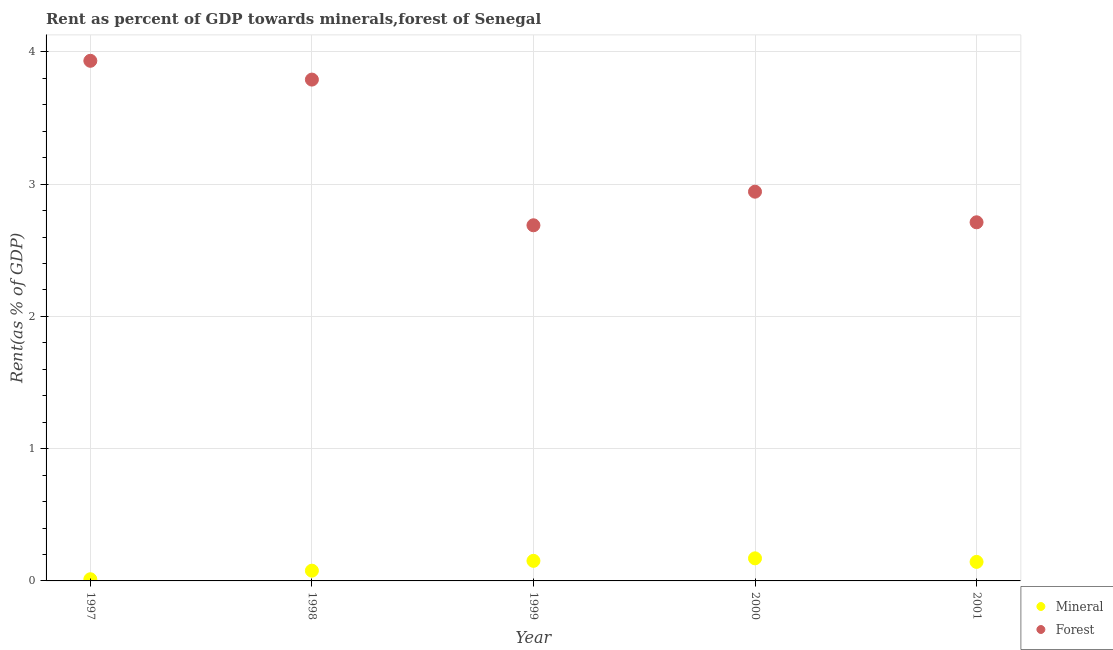How many different coloured dotlines are there?
Ensure brevity in your answer.  2. Is the number of dotlines equal to the number of legend labels?
Make the answer very short. Yes. What is the forest rent in 1998?
Make the answer very short. 3.79. Across all years, what is the maximum forest rent?
Provide a succinct answer. 3.93. Across all years, what is the minimum forest rent?
Offer a very short reply. 2.69. What is the total forest rent in the graph?
Provide a short and direct response. 16.07. What is the difference between the mineral rent in 1997 and that in 1999?
Offer a very short reply. -0.14. What is the difference between the forest rent in 1997 and the mineral rent in 1999?
Offer a terse response. 3.78. What is the average forest rent per year?
Your answer should be compact. 3.21. In the year 1997, what is the difference between the forest rent and mineral rent?
Your response must be concise. 3.92. In how many years, is the forest rent greater than 2.6 %?
Give a very brief answer. 5. What is the ratio of the forest rent in 1998 to that in 2000?
Make the answer very short. 1.29. Is the difference between the forest rent in 1997 and 2000 greater than the difference between the mineral rent in 1997 and 2000?
Ensure brevity in your answer.  Yes. What is the difference between the highest and the second highest forest rent?
Offer a very short reply. 0.14. What is the difference between the highest and the lowest forest rent?
Your answer should be compact. 1.24. How many dotlines are there?
Make the answer very short. 2. How many years are there in the graph?
Make the answer very short. 5. What is the difference between two consecutive major ticks on the Y-axis?
Make the answer very short. 1. Are the values on the major ticks of Y-axis written in scientific E-notation?
Provide a short and direct response. No. Does the graph contain any zero values?
Offer a very short reply. No. Does the graph contain grids?
Make the answer very short. Yes. Where does the legend appear in the graph?
Make the answer very short. Bottom right. How are the legend labels stacked?
Provide a succinct answer. Vertical. What is the title of the graph?
Provide a short and direct response. Rent as percent of GDP towards minerals,forest of Senegal. Does "Chemicals" appear as one of the legend labels in the graph?
Offer a very short reply. No. What is the label or title of the Y-axis?
Offer a very short reply. Rent(as % of GDP). What is the Rent(as % of GDP) of Mineral in 1997?
Keep it short and to the point. 0.01. What is the Rent(as % of GDP) in Forest in 1997?
Give a very brief answer. 3.93. What is the Rent(as % of GDP) of Mineral in 1998?
Ensure brevity in your answer.  0.08. What is the Rent(as % of GDP) of Forest in 1998?
Give a very brief answer. 3.79. What is the Rent(as % of GDP) in Mineral in 1999?
Offer a very short reply. 0.15. What is the Rent(as % of GDP) of Forest in 1999?
Give a very brief answer. 2.69. What is the Rent(as % of GDP) of Mineral in 2000?
Make the answer very short. 0.17. What is the Rent(as % of GDP) of Forest in 2000?
Your response must be concise. 2.94. What is the Rent(as % of GDP) of Mineral in 2001?
Ensure brevity in your answer.  0.14. What is the Rent(as % of GDP) in Forest in 2001?
Your answer should be very brief. 2.71. Across all years, what is the maximum Rent(as % of GDP) of Mineral?
Your answer should be compact. 0.17. Across all years, what is the maximum Rent(as % of GDP) in Forest?
Offer a very short reply. 3.93. Across all years, what is the minimum Rent(as % of GDP) in Mineral?
Offer a very short reply. 0.01. Across all years, what is the minimum Rent(as % of GDP) in Forest?
Keep it short and to the point. 2.69. What is the total Rent(as % of GDP) of Mineral in the graph?
Provide a succinct answer. 0.56. What is the total Rent(as % of GDP) in Forest in the graph?
Make the answer very short. 16.07. What is the difference between the Rent(as % of GDP) in Mineral in 1997 and that in 1998?
Your answer should be very brief. -0.06. What is the difference between the Rent(as % of GDP) of Forest in 1997 and that in 1998?
Your answer should be very brief. 0.14. What is the difference between the Rent(as % of GDP) of Mineral in 1997 and that in 1999?
Give a very brief answer. -0.14. What is the difference between the Rent(as % of GDP) in Forest in 1997 and that in 1999?
Keep it short and to the point. 1.24. What is the difference between the Rent(as % of GDP) of Mineral in 1997 and that in 2000?
Offer a very short reply. -0.16. What is the difference between the Rent(as % of GDP) in Forest in 1997 and that in 2000?
Your answer should be very brief. 0.99. What is the difference between the Rent(as % of GDP) of Mineral in 1997 and that in 2001?
Provide a short and direct response. -0.13. What is the difference between the Rent(as % of GDP) of Forest in 1997 and that in 2001?
Provide a succinct answer. 1.22. What is the difference between the Rent(as % of GDP) of Mineral in 1998 and that in 1999?
Ensure brevity in your answer.  -0.07. What is the difference between the Rent(as % of GDP) in Forest in 1998 and that in 1999?
Your answer should be very brief. 1.1. What is the difference between the Rent(as % of GDP) in Mineral in 1998 and that in 2000?
Offer a terse response. -0.09. What is the difference between the Rent(as % of GDP) in Forest in 1998 and that in 2000?
Give a very brief answer. 0.85. What is the difference between the Rent(as % of GDP) in Mineral in 1998 and that in 2001?
Your response must be concise. -0.07. What is the difference between the Rent(as % of GDP) of Forest in 1998 and that in 2001?
Your answer should be compact. 1.08. What is the difference between the Rent(as % of GDP) in Mineral in 1999 and that in 2000?
Make the answer very short. -0.02. What is the difference between the Rent(as % of GDP) of Forest in 1999 and that in 2000?
Your answer should be compact. -0.25. What is the difference between the Rent(as % of GDP) of Mineral in 1999 and that in 2001?
Provide a succinct answer. 0.01. What is the difference between the Rent(as % of GDP) of Forest in 1999 and that in 2001?
Make the answer very short. -0.02. What is the difference between the Rent(as % of GDP) of Mineral in 2000 and that in 2001?
Keep it short and to the point. 0.03. What is the difference between the Rent(as % of GDP) of Forest in 2000 and that in 2001?
Ensure brevity in your answer.  0.23. What is the difference between the Rent(as % of GDP) in Mineral in 1997 and the Rent(as % of GDP) in Forest in 1998?
Offer a very short reply. -3.78. What is the difference between the Rent(as % of GDP) of Mineral in 1997 and the Rent(as % of GDP) of Forest in 1999?
Provide a succinct answer. -2.68. What is the difference between the Rent(as % of GDP) in Mineral in 1997 and the Rent(as % of GDP) in Forest in 2000?
Ensure brevity in your answer.  -2.93. What is the difference between the Rent(as % of GDP) in Mineral in 1997 and the Rent(as % of GDP) in Forest in 2001?
Your answer should be compact. -2.7. What is the difference between the Rent(as % of GDP) in Mineral in 1998 and the Rent(as % of GDP) in Forest in 1999?
Make the answer very short. -2.61. What is the difference between the Rent(as % of GDP) of Mineral in 1998 and the Rent(as % of GDP) of Forest in 2000?
Provide a succinct answer. -2.87. What is the difference between the Rent(as % of GDP) of Mineral in 1998 and the Rent(as % of GDP) of Forest in 2001?
Provide a succinct answer. -2.63. What is the difference between the Rent(as % of GDP) in Mineral in 1999 and the Rent(as % of GDP) in Forest in 2000?
Make the answer very short. -2.79. What is the difference between the Rent(as % of GDP) in Mineral in 1999 and the Rent(as % of GDP) in Forest in 2001?
Make the answer very short. -2.56. What is the difference between the Rent(as % of GDP) in Mineral in 2000 and the Rent(as % of GDP) in Forest in 2001?
Give a very brief answer. -2.54. What is the average Rent(as % of GDP) of Mineral per year?
Provide a short and direct response. 0.11. What is the average Rent(as % of GDP) in Forest per year?
Your answer should be compact. 3.21. In the year 1997, what is the difference between the Rent(as % of GDP) in Mineral and Rent(as % of GDP) in Forest?
Offer a very short reply. -3.92. In the year 1998, what is the difference between the Rent(as % of GDP) of Mineral and Rent(as % of GDP) of Forest?
Your answer should be very brief. -3.71. In the year 1999, what is the difference between the Rent(as % of GDP) of Mineral and Rent(as % of GDP) of Forest?
Your response must be concise. -2.54. In the year 2000, what is the difference between the Rent(as % of GDP) of Mineral and Rent(as % of GDP) of Forest?
Provide a short and direct response. -2.77. In the year 2001, what is the difference between the Rent(as % of GDP) in Mineral and Rent(as % of GDP) in Forest?
Make the answer very short. -2.57. What is the ratio of the Rent(as % of GDP) of Mineral in 1997 to that in 1998?
Make the answer very short. 0.16. What is the ratio of the Rent(as % of GDP) of Forest in 1997 to that in 1998?
Provide a short and direct response. 1.04. What is the ratio of the Rent(as % of GDP) of Mineral in 1997 to that in 1999?
Provide a succinct answer. 0.08. What is the ratio of the Rent(as % of GDP) of Forest in 1997 to that in 1999?
Offer a terse response. 1.46. What is the ratio of the Rent(as % of GDP) of Mineral in 1997 to that in 2000?
Your response must be concise. 0.07. What is the ratio of the Rent(as % of GDP) of Forest in 1997 to that in 2000?
Make the answer very short. 1.34. What is the ratio of the Rent(as % of GDP) of Mineral in 1997 to that in 2001?
Provide a short and direct response. 0.09. What is the ratio of the Rent(as % of GDP) of Forest in 1997 to that in 2001?
Keep it short and to the point. 1.45. What is the ratio of the Rent(as % of GDP) of Mineral in 1998 to that in 1999?
Your response must be concise. 0.51. What is the ratio of the Rent(as % of GDP) of Forest in 1998 to that in 1999?
Ensure brevity in your answer.  1.41. What is the ratio of the Rent(as % of GDP) in Mineral in 1998 to that in 2000?
Give a very brief answer. 0.45. What is the ratio of the Rent(as % of GDP) in Forest in 1998 to that in 2000?
Provide a succinct answer. 1.29. What is the ratio of the Rent(as % of GDP) in Mineral in 1998 to that in 2001?
Your response must be concise. 0.54. What is the ratio of the Rent(as % of GDP) of Forest in 1998 to that in 2001?
Offer a terse response. 1.4. What is the ratio of the Rent(as % of GDP) of Mineral in 1999 to that in 2000?
Provide a short and direct response. 0.89. What is the ratio of the Rent(as % of GDP) of Forest in 1999 to that in 2000?
Offer a terse response. 0.91. What is the ratio of the Rent(as % of GDP) of Mineral in 1999 to that in 2001?
Make the answer very short. 1.06. What is the ratio of the Rent(as % of GDP) of Forest in 1999 to that in 2001?
Your answer should be compact. 0.99. What is the ratio of the Rent(as % of GDP) in Mineral in 2000 to that in 2001?
Keep it short and to the point. 1.19. What is the ratio of the Rent(as % of GDP) of Forest in 2000 to that in 2001?
Give a very brief answer. 1.09. What is the difference between the highest and the second highest Rent(as % of GDP) in Mineral?
Ensure brevity in your answer.  0.02. What is the difference between the highest and the second highest Rent(as % of GDP) in Forest?
Provide a succinct answer. 0.14. What is the difference between the highest and the lowest Rent(as % of GDP) in Mineral?
Offer a terse response. 0.16. What is the difference between the highest and the lowest Rent(as % of GDP) of Forest?
Ensure brevity in your answer.  1.24. 